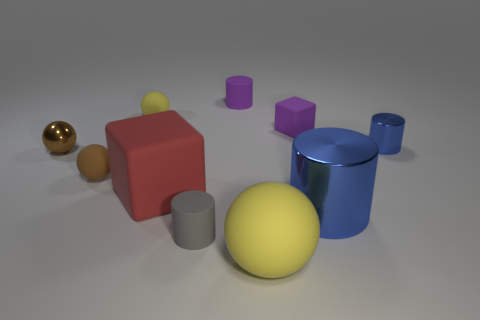Is the number of rubber balls in front of the big cylinder greater than the number of big red metallic things?
Your answer should be compact. Yes. Is the material of the tiny purple cylinder the same as the small yellow thing?
Provide a short and direct response. Yes. How many things are matte objects that are on the left side of the tiny rubber cube or brown metal things?
Your response must be concise. 7. How many other objects are there of the same size as the red rubber object?
Offer a very short reply. 2. Is the number of gray cylinders that are right of the large blue metal cylinder the same as the number of large shiny objects behind the small brown metal ball?
Provide a short and direct response. Yes. The other thing that is the same shape as the big red rubber object is what color?
Your answer should be compact. Purple. Does the cylinder that is on the right side of the big blue metallic cylinder have the same color as the big cylinder?
Your response must be concise. Yes. The other brown thing that is the same shape as the brown rubber object is what size?
Ensure brevity in your answer.  Small. How many tiny cylinders are made of the same material as the large cube?
Offer a terse response. 2. Is there a rubber cylinder that is behind the small shiny thing right of the cylinder that is in front of the large cylinder?
Ensure brevity in your answer.  Yes. 